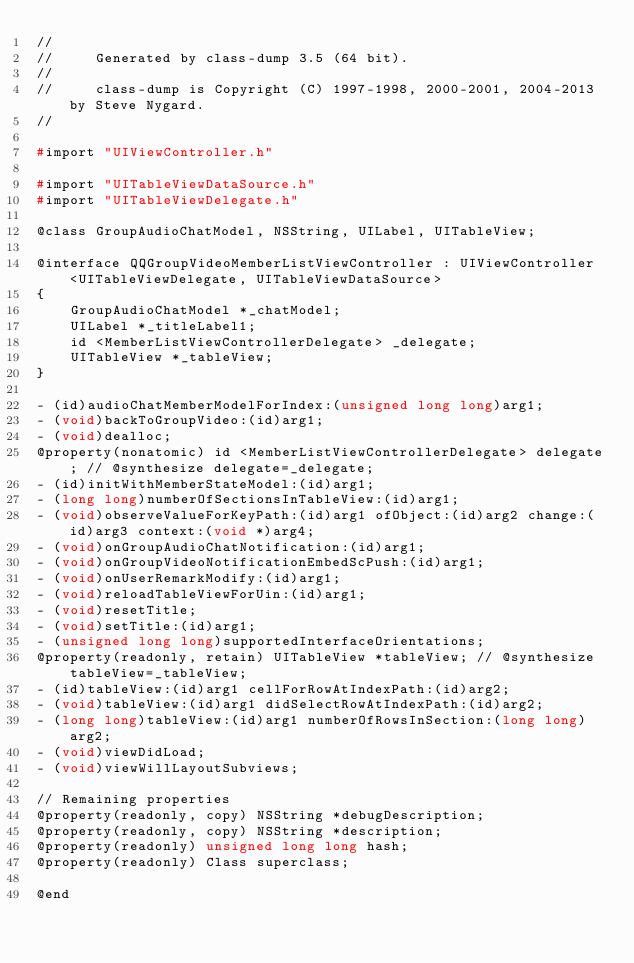Convert code to text. <code><loc_0><loc_0><loc_500><loc_500><_C_>//
//     Generated by class-dump 3.5 (64 bit).
//
//     class-dump is Copyright (C) 1997-1998, 2000-2001, 2004-2013 by Steve Nygard.
//

#import "UIViewController.h"

#import "UITableViewDataSource.h"
#import "UITableViewDelegate.h"

@class GroupAudioChatModel, NSString, UILabel, UITableView;

@interface QQGroupVideoMemberListViewController : UIViewController <UITableViewDelegate, UITableViewDataSource>
{
    GroupAudioChatModel *_chatModel;
    UILabel *_titleLabel1;
    id <MemberListViewControllerDelegate> _delegate;
    UITableView *_tableView;
}

- (id)audioChatMemberModelForIndex:(unsigned long long)arg1;
- (void)backToGroupVideo:(id)arg1;
- (void)dealloc;
@property(nonatomic) id <MemberListViewControllerDelegate> delegate; // @synthesize delegate=_delegate;
- (id)initWithMemberStateModel:(id)arg1;
- (long long)numberOfSectionsInTableView:(id)arg1;
- (void)observeValueForKeyPath:(id)arg1 ofObject:(id)arg2 change:(id)arg3 context:(void *)arg4;
- (void)onGroupAudioChatNotification:(id)arg1;
- (void)onGroupVideoNotificationEmbedScPush:(id)arg1;
- (void)onUserRemarkModify:(id)arg1;
- (void)reloadTableViewForUin:(id)arg1;
- (void)resetTitle;
- (void)setTitle:(id)arg1;
- (unsigned long long)supportedInterfaceOrientations;
@property(readonly, retain) UITableView *tableView; // @synthesize tableView=_tableView;
- (id)tableView:(id)arg1 cellForRowAtIndexPath:(id)arg2;
- (void)tableView:(id)arg1 didSelectRowAtIndexPath:(id)arg2;
- (long long)tableView:(id)arg1 numberOfRowsInSection:(long long)arg2;
- (void)viewDidLoad;
- (void)viewWillLayoutSubviews;

// Remaining properties
@property(readonly, copy) NSString *debugDescription;
@property(readonly, copy) NSString *description;
@property(readonly) unsigned long long hash;
@property(readonly) Class superclass;

@end

</code> 